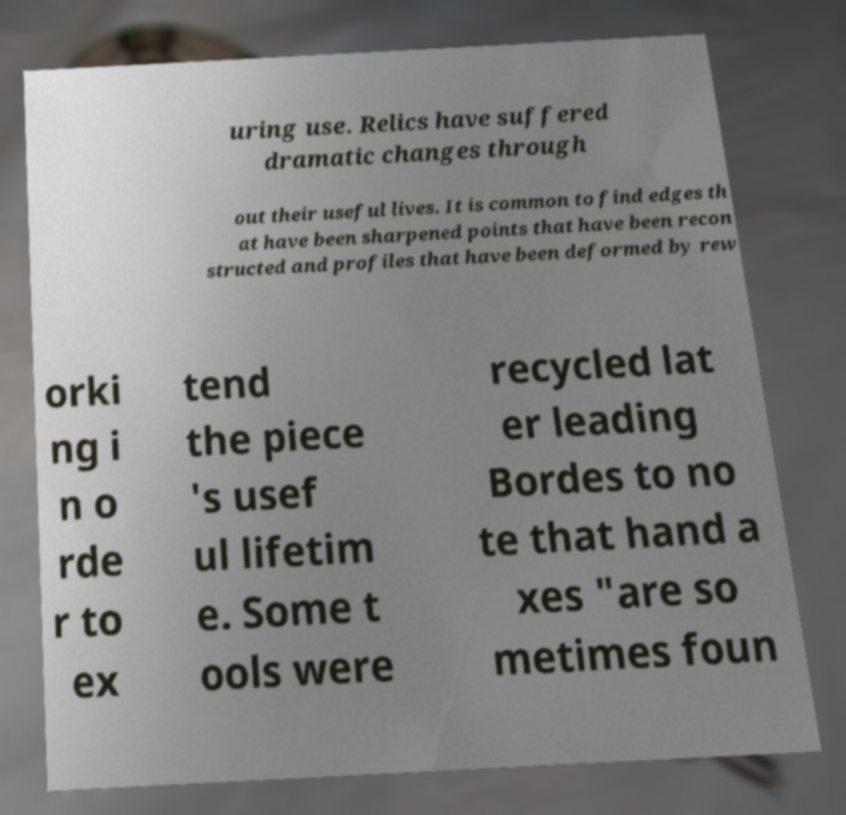Could you extract and type out the text from this image? uring use. Relics have suffered dramatic changes through out their useful lives. It is common to find edges th at have been sharpened points that have been recon structed and profiles that have been deformed by rew orki ng i n o rde r to ex tend the piece 's usef ul lifetim e. Some t ools were recycled lat er leading Bordes to no te that hand a xes "are so metimes foun 